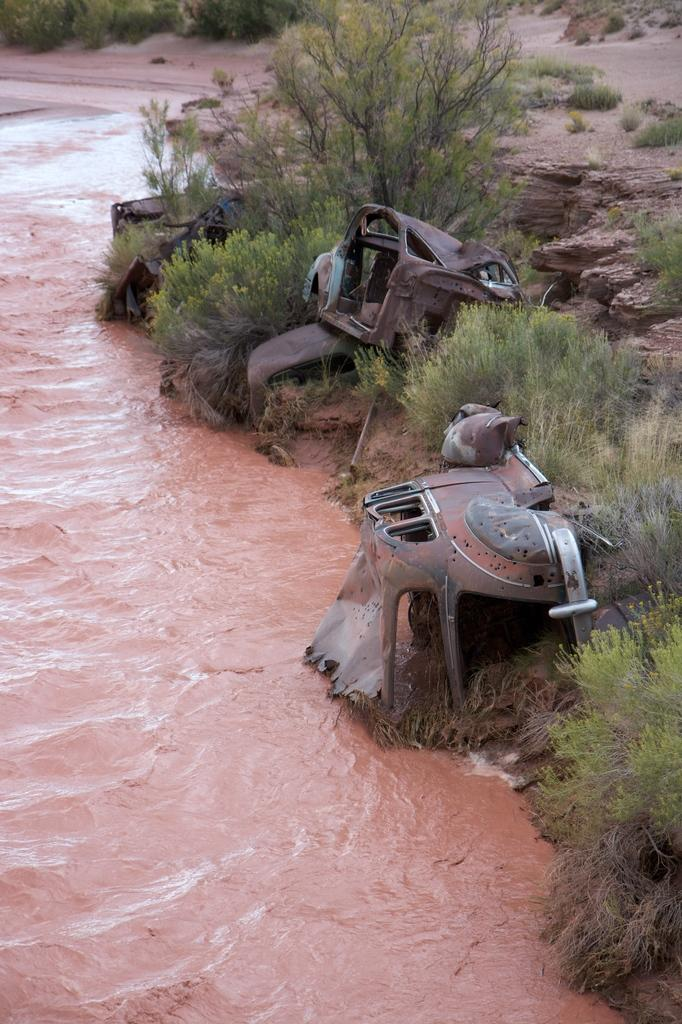What type of vegetation is present in the image? There are trees in the image. What natural element can be seen in the image besides trees? There is water visible in the image. What type of ground cover is present in the image? There is grass in the image. How many horses are visible in the image? There are no horses present in the image. What type of shade is provided by the trees in the image? There is no mention of shade in the image; it only states that there are trees present. 